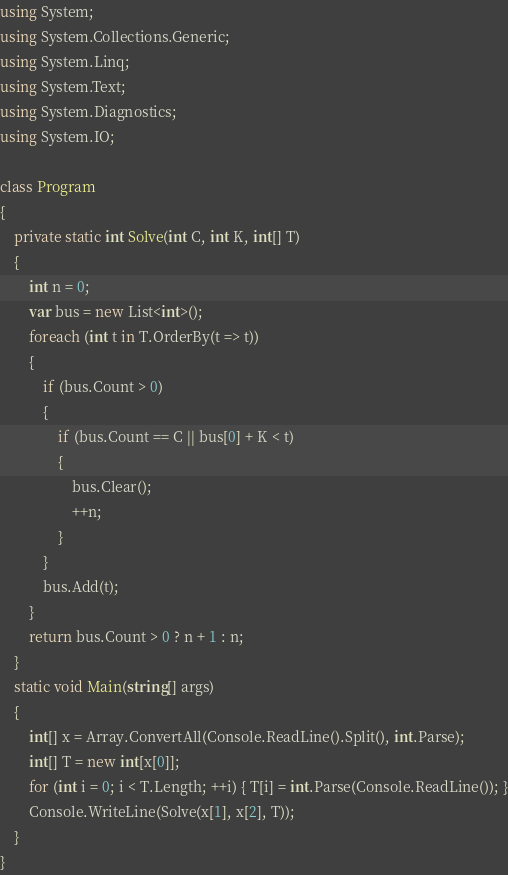<code> <loc_0><loc_0><loc_500><loc_500><_C#_>using System;
using System.Collections.Generic;
using System.Linq;
using System.Text;
using System.Diagnostics;
using System.IO;

class Program
{
    private static int Solve(int C, int K, int[] T)
    {
        int n = 0;
        var bus = new List<int>();
        foreach (int t in T.OrderBy(t => t))
        {
            if (bus.Count > 0)
            {
                if (bus.Count == C || bus[0] + K < t)
                {
                    bus.Clear();
                    ++n;
                }
            }
            bus.Add(t);
        }
        return bus.Count > 0 ? n + 1 : n;
    }
    static void Main(string[] args)
    {
        int[] x = Array.ConvertAll(Console.ReadLine().Split(), int.Parse);
        int[] T = new int[x[0]];
        for (int i = 0; i < T.Length; ++i) { T[i] = int.Parse(Console.ReadLine()); }
        Console.WriteLine(Solve(x[1], x[2], T));
    }
}
</code> 